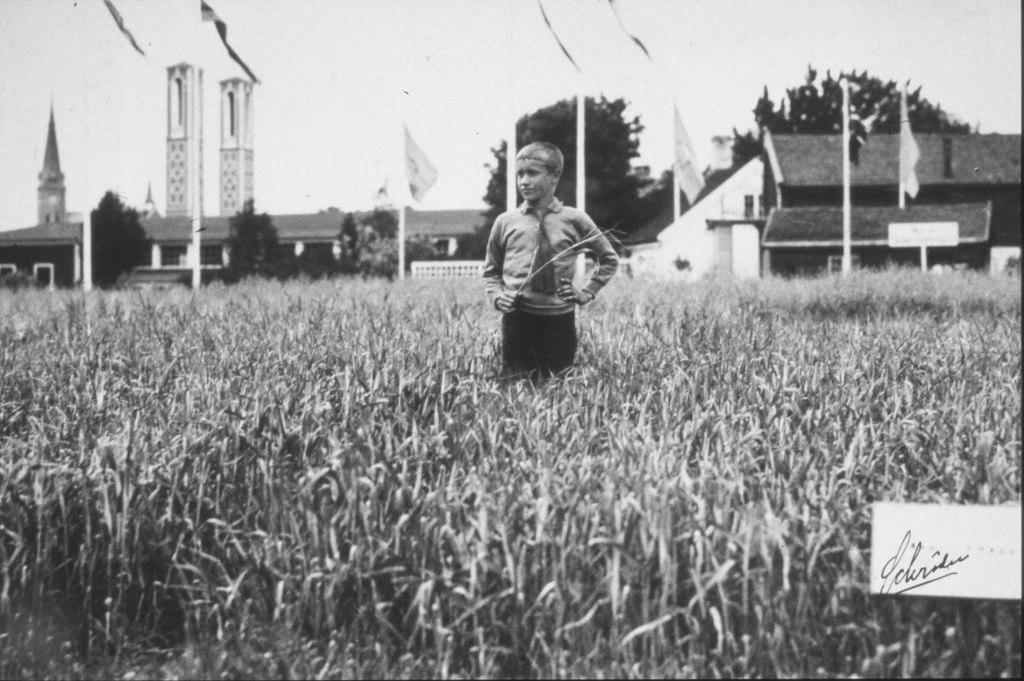Please provide a concise description of this image. This is a black and white image. In the center of the image there is a boy. At the bottom of the image there are crops. In the background of the image there are houses. There are trees. There are flags. At the top of the image there is sky. 